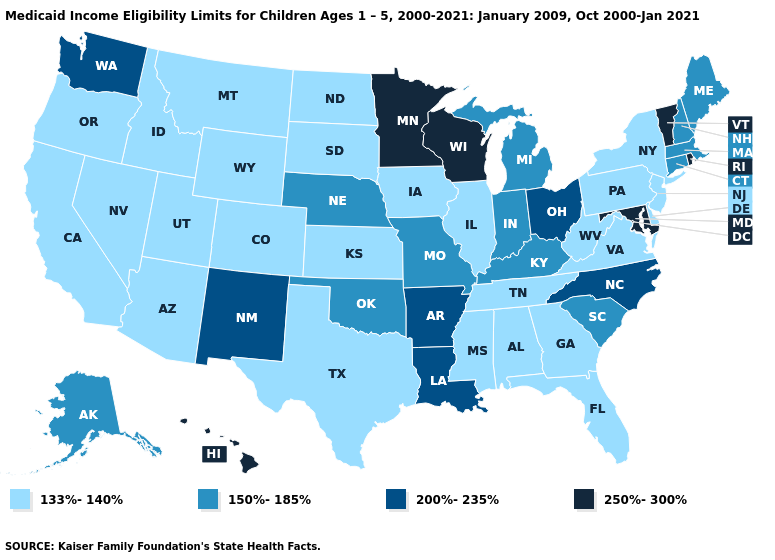What is the value of Pennsylvania?
Write a very short answer. 133%-140%. Which states have the lowest value in the USA?
Short answer required. Alabama, Arizona, California, Colorado, Delaware, Florida, Georgia, Idaho, Illinois, Iowa, Kansas, Mississippi, Montana, Nevada, New Jersey, New York, North Dakota, Oregon, Pennsylvania, South Dakota, Tennessee, Texas, Utah, Virginia, West Virginia, Wyoming. Name the states that have a value in the range 250%-300%?
Short answer required. Hawaii, Maryland, Minnesota, Rhode Island, Vermont, Wisconsin. Among the states that border Connecticut , does Massachusetts have the lowest value?
Be succinct. No. Does the first symbol in the legend represent the smallest category?
Concise answer only. Yes. What is the value of Kentucky?
Quick response, please. 150%-185%. Name the states that have a value in the range 133%-140%?
Concise answer only. Alabama, Arizona, California, Colorado, Delaware, Florida, Georgia, Idaho, Illinois, Iowa, Kansas, Mississippi, Montana, Nevada, New Jersey, New York, North Dakota, Oregon, Pennsylvania, South Dakota, Tennessee, Texas, Utah, Virginia, West Virginia, Wyoming. What is the value of Iowa?
Short answer required. 133%-140%. Does Arizona have the lowest value in the West?
Write a very short answer. Yes. Name the states that have a value in the range 250%-300%?
Write a very short answer. Hawaii, Maryland, Minnesota, Rhode Island, Vermont, Wisconsin. Which states have the highest value in the USA?
Answer briefly. Hawaii, Maryland, Minnesota, Rhode Island, Vermont, Wisconsin. How many symbols are there in the legend?
Quick response, please. 4. Name the states that have a value in the range 150%-185%?
Short answer required. Alaska, Connecticut, Indiana, Kentucky, Maine, Massachusetts, Michigan, Missouri, Nebraska, New Hampshire, Oklahoma, South Carolina. Does Missouri have a higher value than Illinois?
Write a very short answer. Yes. Name the states that have a value in the range 250%-300%?
Quick response, please. Hawaii, Maryland, Minnesota, Rhode Island, Vermont, Wisconsin. 